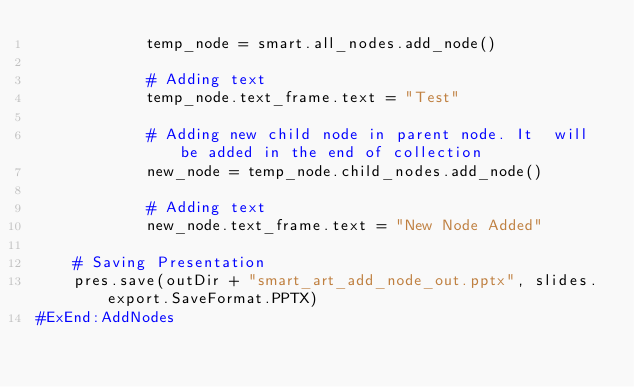Convert code to text. <code><loc_0><loc_0><loc_500><loc_500><_Python_>            temp_node = smart.all_nodes.add_node()

            # Adding text
            temp_node.text_frame.text = "Test"

            # Adding new child node in parent node. It  will be added in the end of collection
            new_node = temp_node.child_nodes.add_node()

            # Adding text
            new_node.text_frame.text = "New Node Added"

    # Saving Presentation
    pres.save(outDir + "smart_art_add_node_out.pptx", slides.export.SaveFormat.PPTX)
#ExEnd:AddNodes</code> 